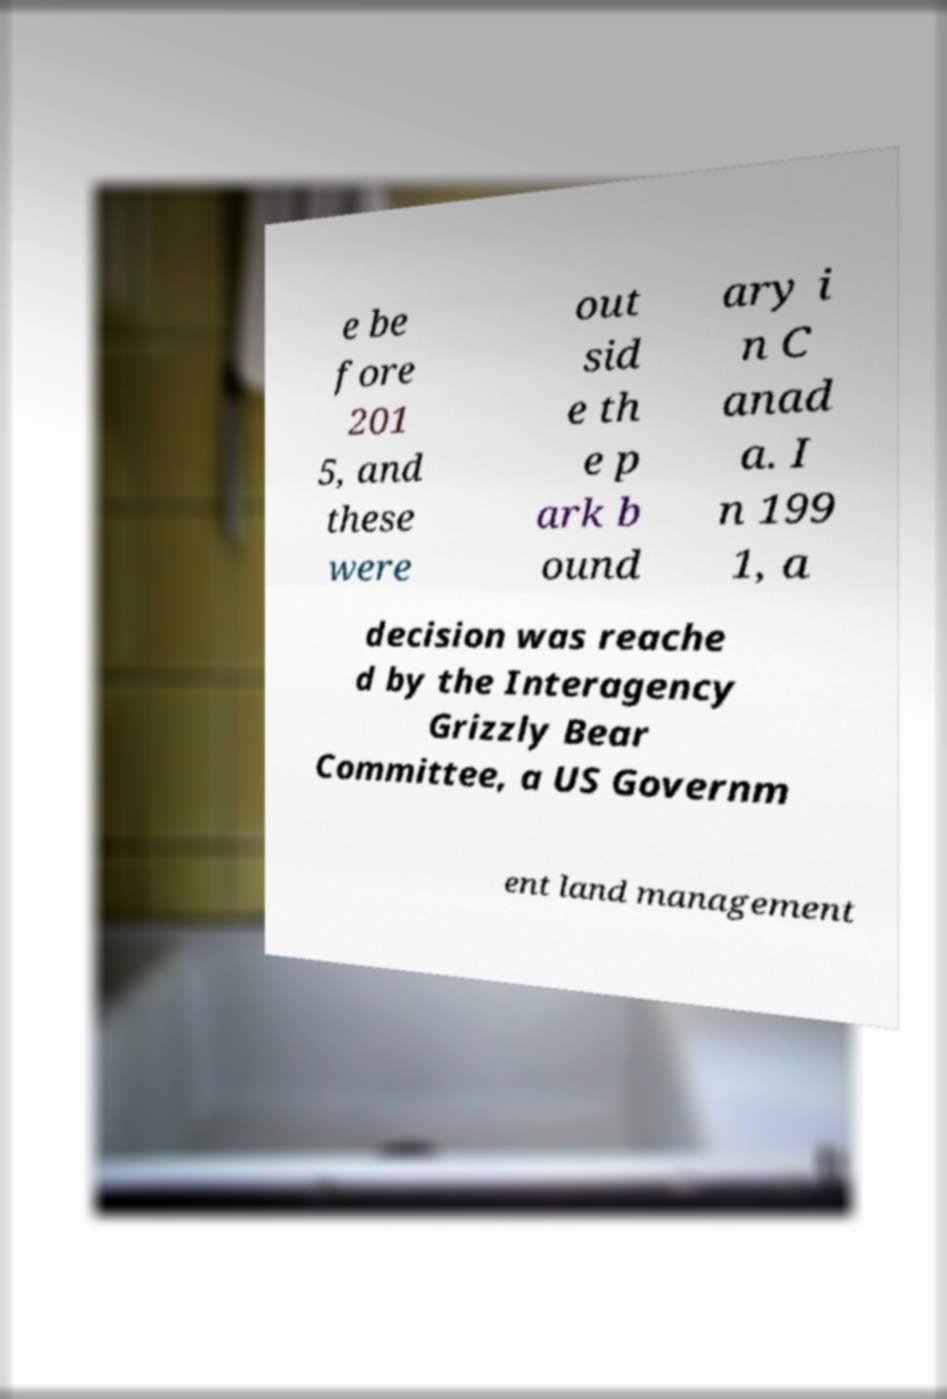What messages or text are displayed in this image? I need them in a readable, typed format. e be fore 201 5, and these were out sid e th e p ark b ound ary i n C anad a. I n 199 1, a decision was reache d by the Interagency Grizzly Bear Committee, a US Governm ent land management 